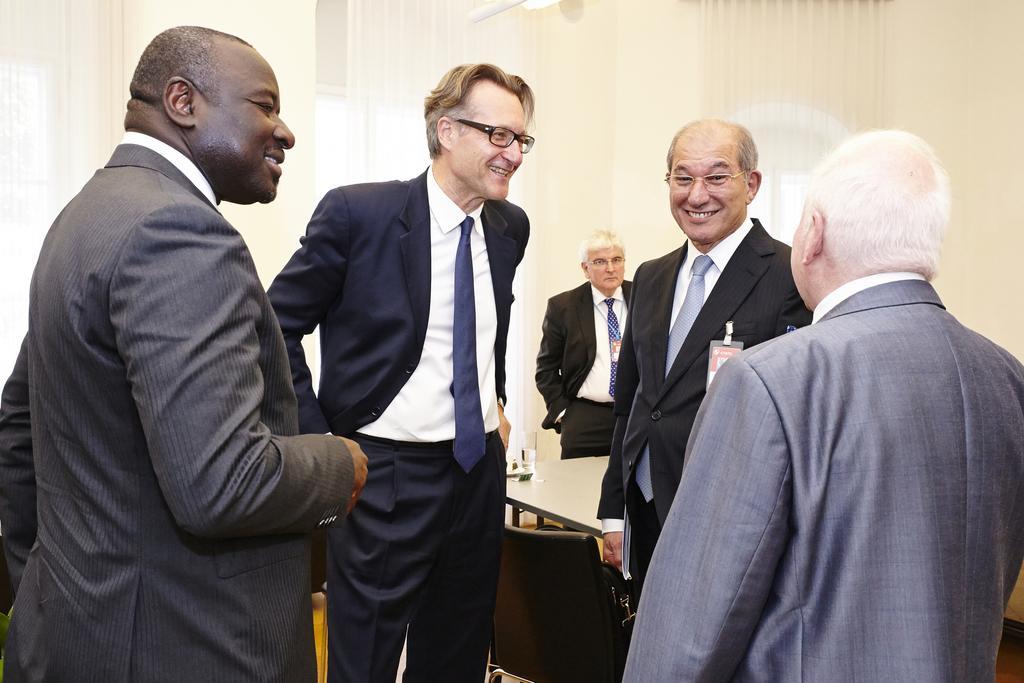Could you give a brief overview of what you see in this image? In this image I can see group of people are standing. These people are wearing suits and smiling. In the background I can see a wall and curtains. I can also see a chair and a table. 